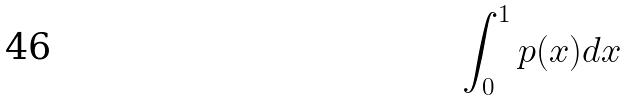Convert formula to latex. <formula><loc_0><loc_0><loc_500><loc_500>\int _ { 0 } ^ { 1 } p ( x ) d x</formula> 